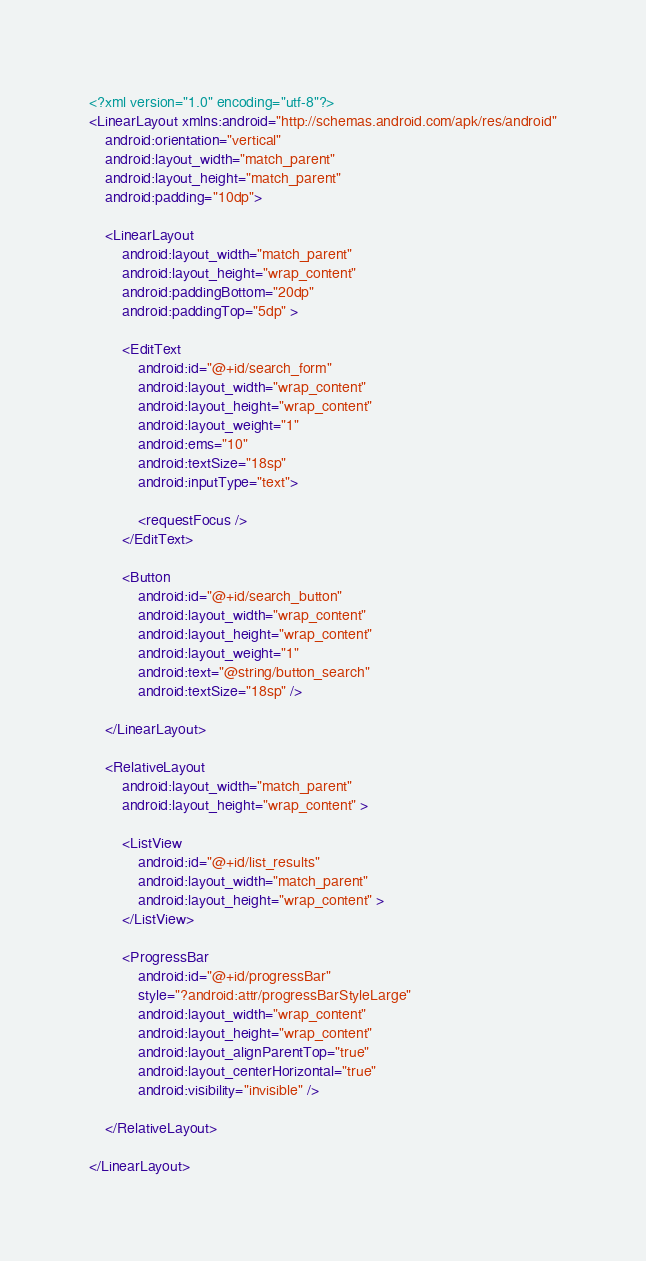<code> <loc_0><loc_0><loc_500><loc_500><_XML_><?xml version="1.0" encoding="utf-8"?>
<LinearLayout xmlns:android="http://schemas.android.com/apk/res/android"
    android:orientation="vertical"
    android:layout_width="match_parent"
    android:layout_height="match_parent"
    android:padding="10dp">

    <LinearLayout
        android:layout_width="match_parent"
        android:layout_height="wrap_content"
        android:paddingBottom="20dp"
        android:paddingTop="5dp" >

        <EditText
            android:id="@+id/search_form"
            android:layout_width="wrap_content"
            android:layout_height="wrap_content"
            android:layout_weight="1"
            android:ems="10"
            android:textSize="18sp"
            android:inputType="text">

            <requestFocus />
        </EditText>

        <Button
            android:id="@+id/search_button"
            android:layout_width="wrap_content"
            android:layout_height="wrap_content"
            android:layout_weight="1"
            android:text="@string/button_search"
            android:textSize="18sp" />

    </LinearLayout>

    <RelativeLayout
        android:layout_width="match_parent"
        android:layout_height="wrap_content" >

        <ListView
            android:id="@+id/list_results"
            android:layout_width="match_parent"
            android:layout_height="wrap_content" >
        </ListView>

        <ProgressBar
            android:id="@+id/progressBar"
            style="?android:attr/progressBarStyleLarge"
            android:layout_width="wrap_content"
            android:layout_height="wrap_content"
            android:layout_alignParentTop="true"
            android:layout_centerHorizontal="true"
            android:visibility="invisible" />

    </RelativeLayout>

</LinearLayout></code> 